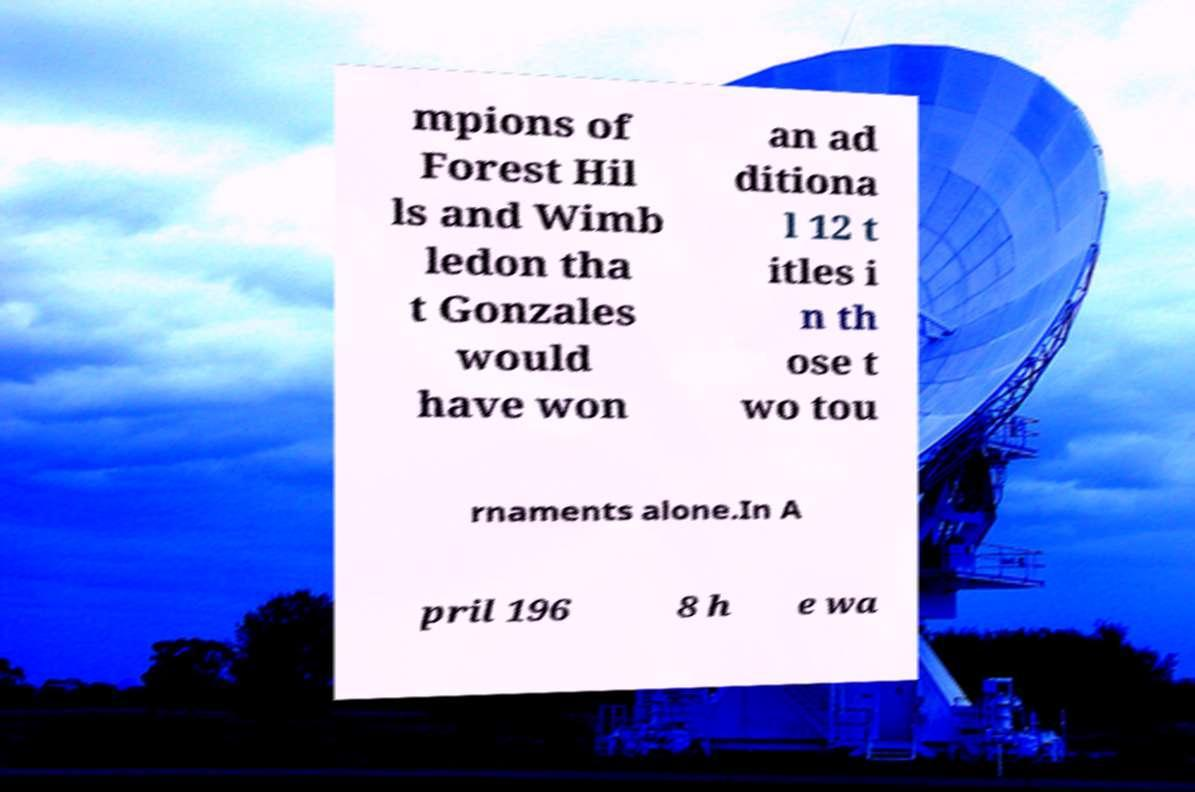What messages or text are displayed in this image? I need them in a readable, typed format. mpions of Forest Hil ls and Wimb ledon tha t Gonzales would have won an ad ditiona l 12 t itles i n th ose t wo tou rnaments alone.In A pril 196 8 h e wa 